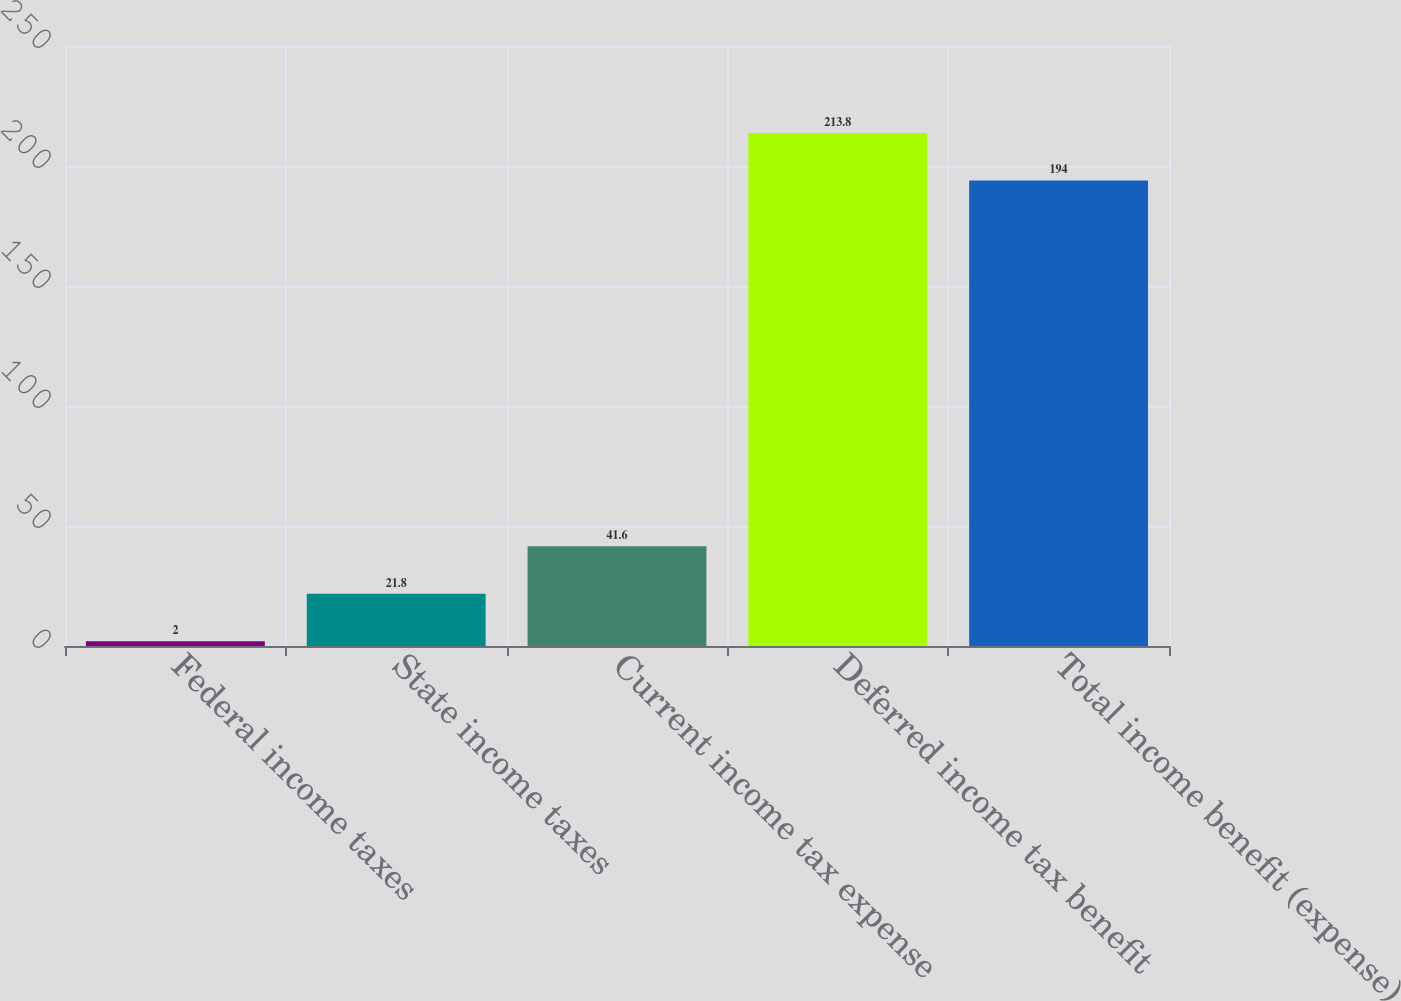Convert chart. <chart><loc_0><loc_0><loc_500><loc_500><bar_chart><fcel>Federal income taxes<fcel>State income taxes<fcel>Current income tax expense<fcel>Deferred income tax benefit<fcel>Total income benefit (expense)<nl><fcel>2<fcel>21.8<fcel>41.6<fcel>213.8<fcel>194<nl></chart> 